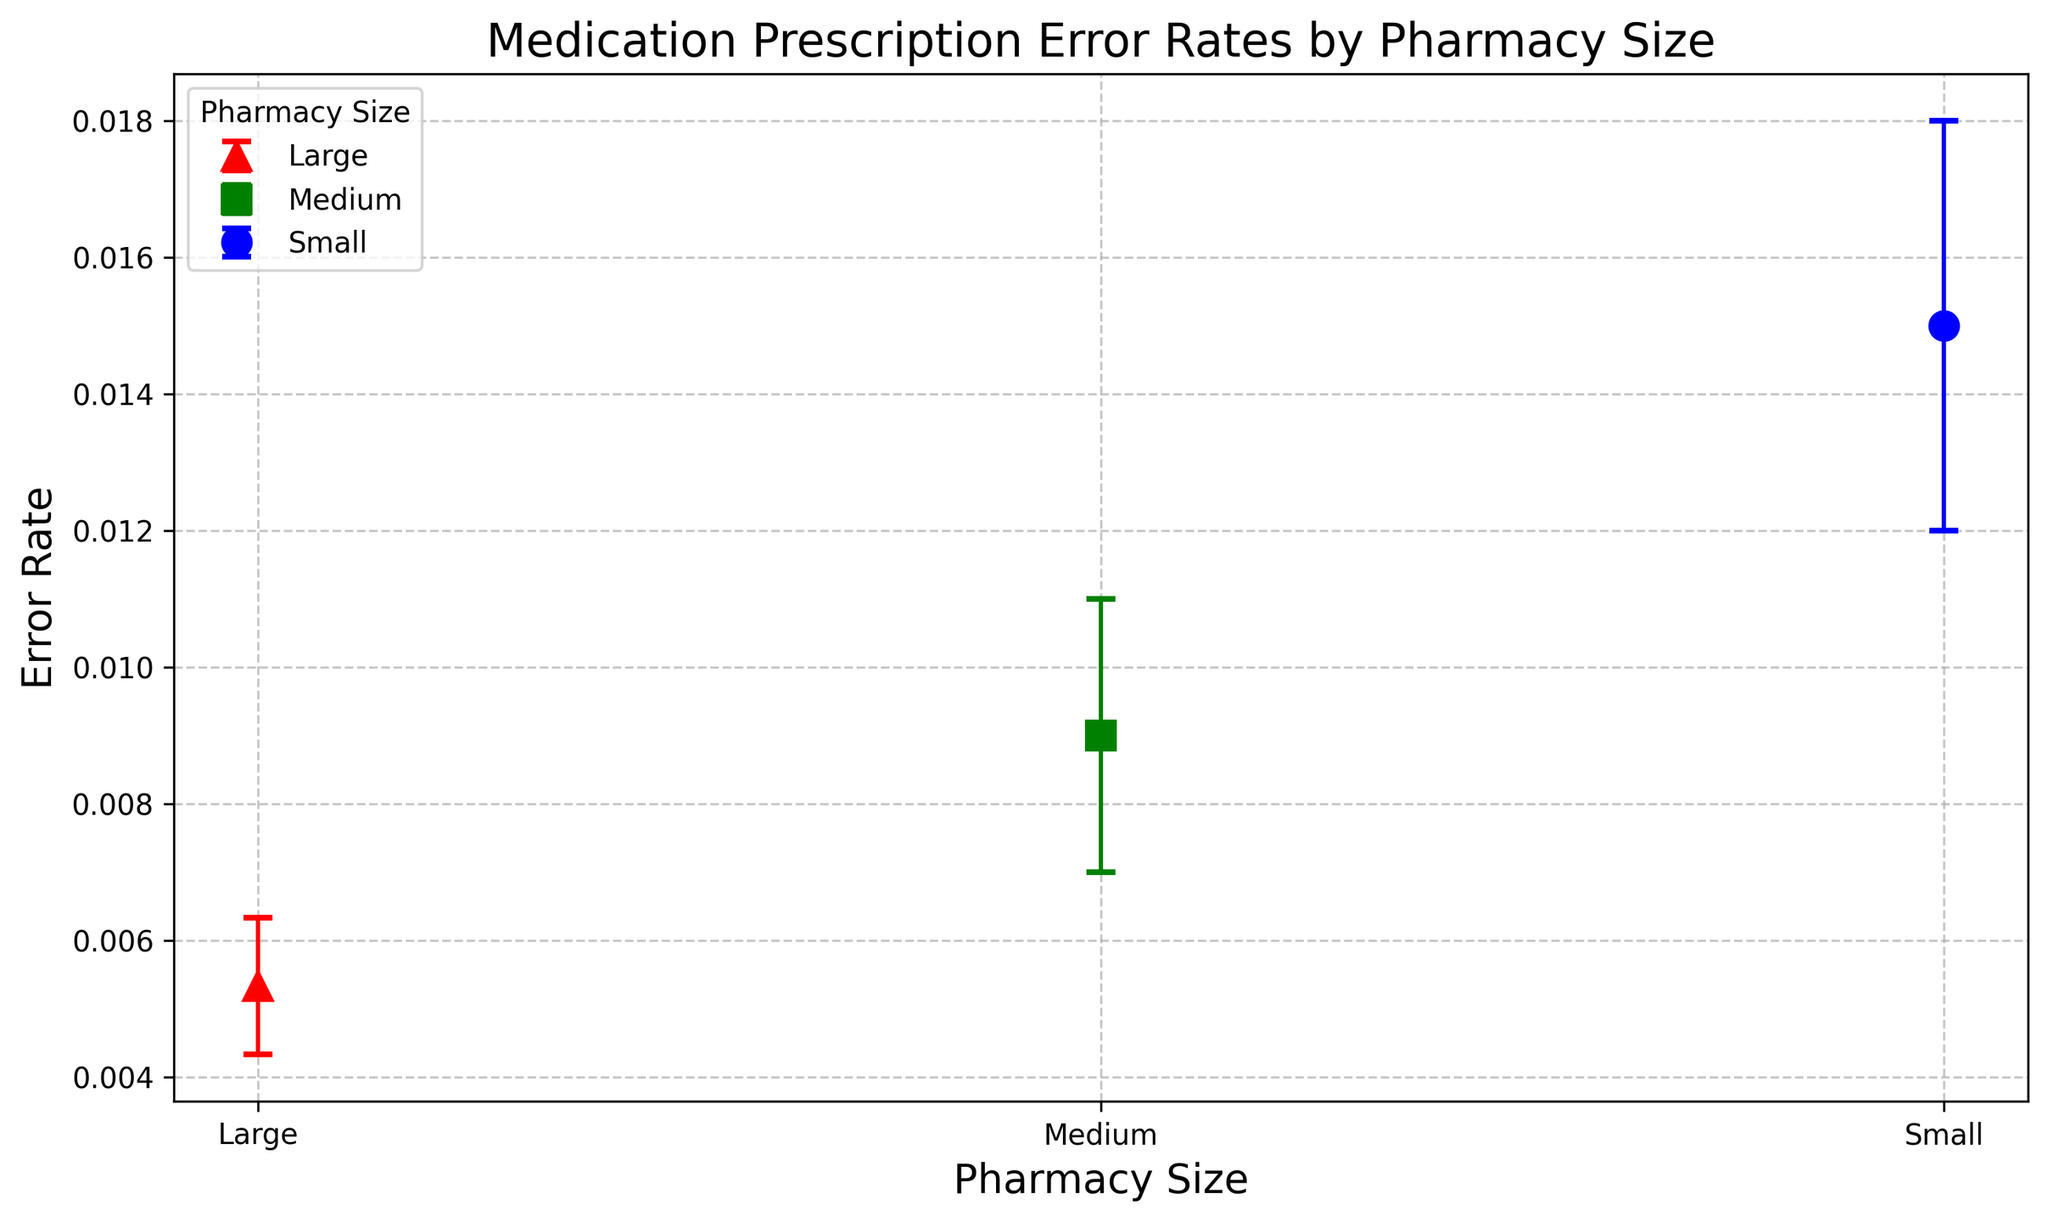What is the average medication prescription error rate for small pharmacies? To calculate the average error rate for small pharmacies, take the sum of the three provided error rates (0.015, 0.014, 0.016) and divide by the number of data points (3). The sum is 0.045, and dividing by 3 gives an average error rate of 0.015.
Answer: 0.015 Which pharmacy size has the lowest average error rate? By comparing the average error rates of each pharmacy size, we see that small pharmacies have an average of 0.015, medium pharmacies have an average of 0.009, and large pharmacies have an average of 0.005. The lowest average error rate is 0.005 for large pharmacies.
Answer: Large How much higher is the average error rate of small pharmacies compared to large pharmacies? The average error rate for small pharmacies is 0.015, and for large pharmacies, it is 0.005. The difference between them is 0.015 - 0.005 = 0.01.
Answer: 0.01 What is the sum of the upper confidence interval bounds for medium pharmacies? Sum the upper confidence interval bounds for the three medium pharmacy data points: 0.011, 0.010, and 0.012. The sum is 0.011 + 0.010 + 0.012 = 0.033.
Answer: 0.033 Which pharmacy size has the widest confidence interval? By comparing the confidence intervals, we see that small pharmacies have an interval from approximately 0.011 to 0.019 (range roughly 0.008), medium pharmacies from 0.006 to 0.012 (range roughly 0.006), and large pharmacies from 0.004 to 0.007 (range roughly 0.003). Small pharmacies have the widest confidence interval.
Answer: Small What is the difference between the upper and lower confidence intervals of the smallest error rate in large pharmacies? The smallest error rate for large pharmacies is 0.005, with a lower confidence interval of 0.004 and an upper confidence interval of 0.006. The difference is 0.006 - 0.004 = 0.002.
Answer: 0.002 Which pharmacy size is represented by a red marker in the plot? By the visual attributes described, red color is used for large pharmacies.
Answer: Large What is the visual trend in error rates as pharmacy size increases? Observing the plot, the error rates decrease as the pharmacy size increases: small pharmacies have the highest average error rate, followed by medium and then large pharmacies.
Answer: Decrease 